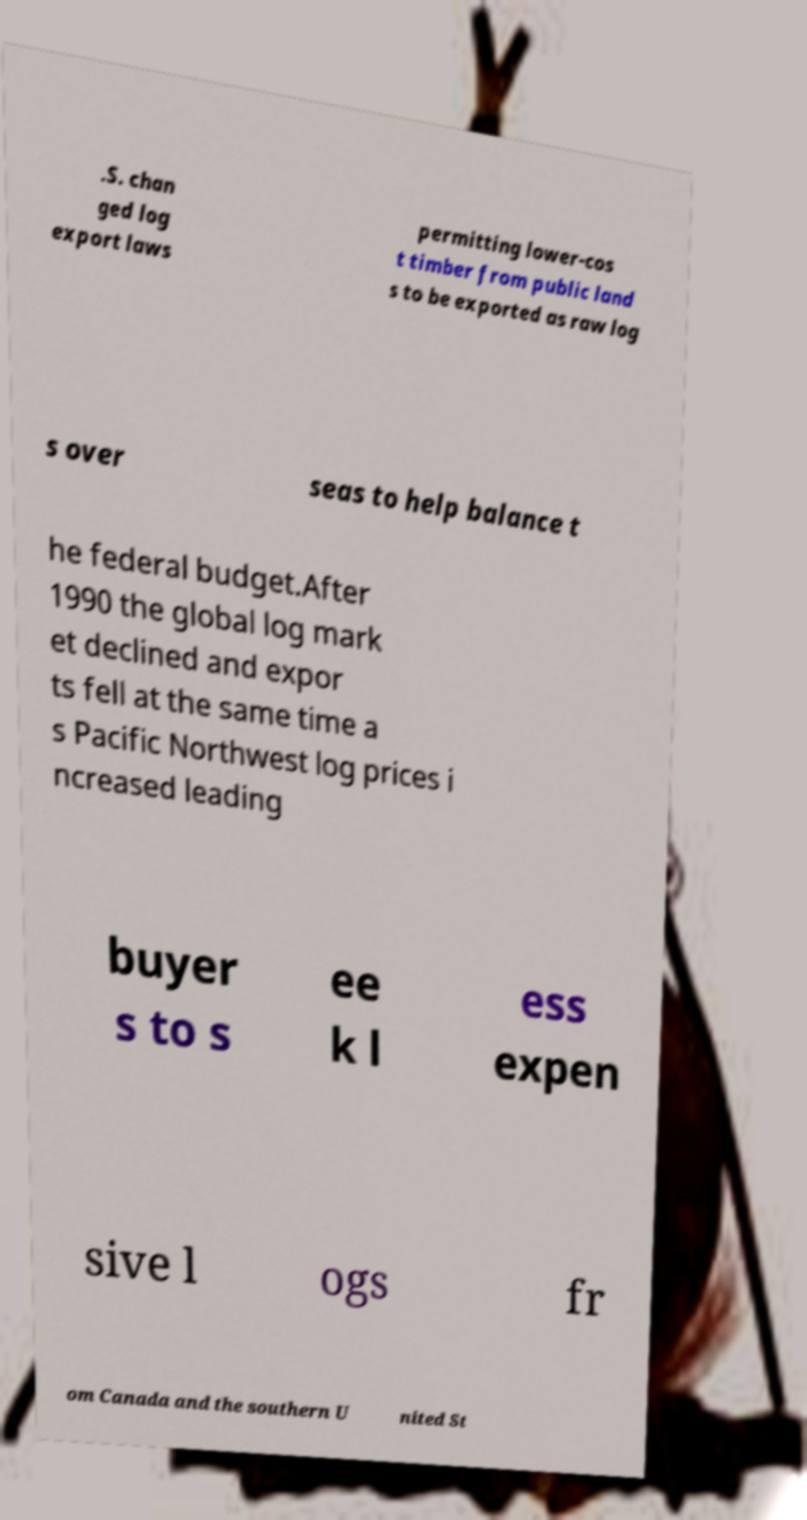Could you assist in decoding the text presented in this image and type it out clearly? .S. chan ged log export laws permitting lower-cos t timber from public land s to be exported as raw log s over seas to help balance t he federal budget.After 1990 the global log mark et declined and expor ts fell at the same time a s Pacific Northwest log prices i ncreased leading buyer s to s ee k l ess expen sive l ogs fr om Canada and the southern U nited St 